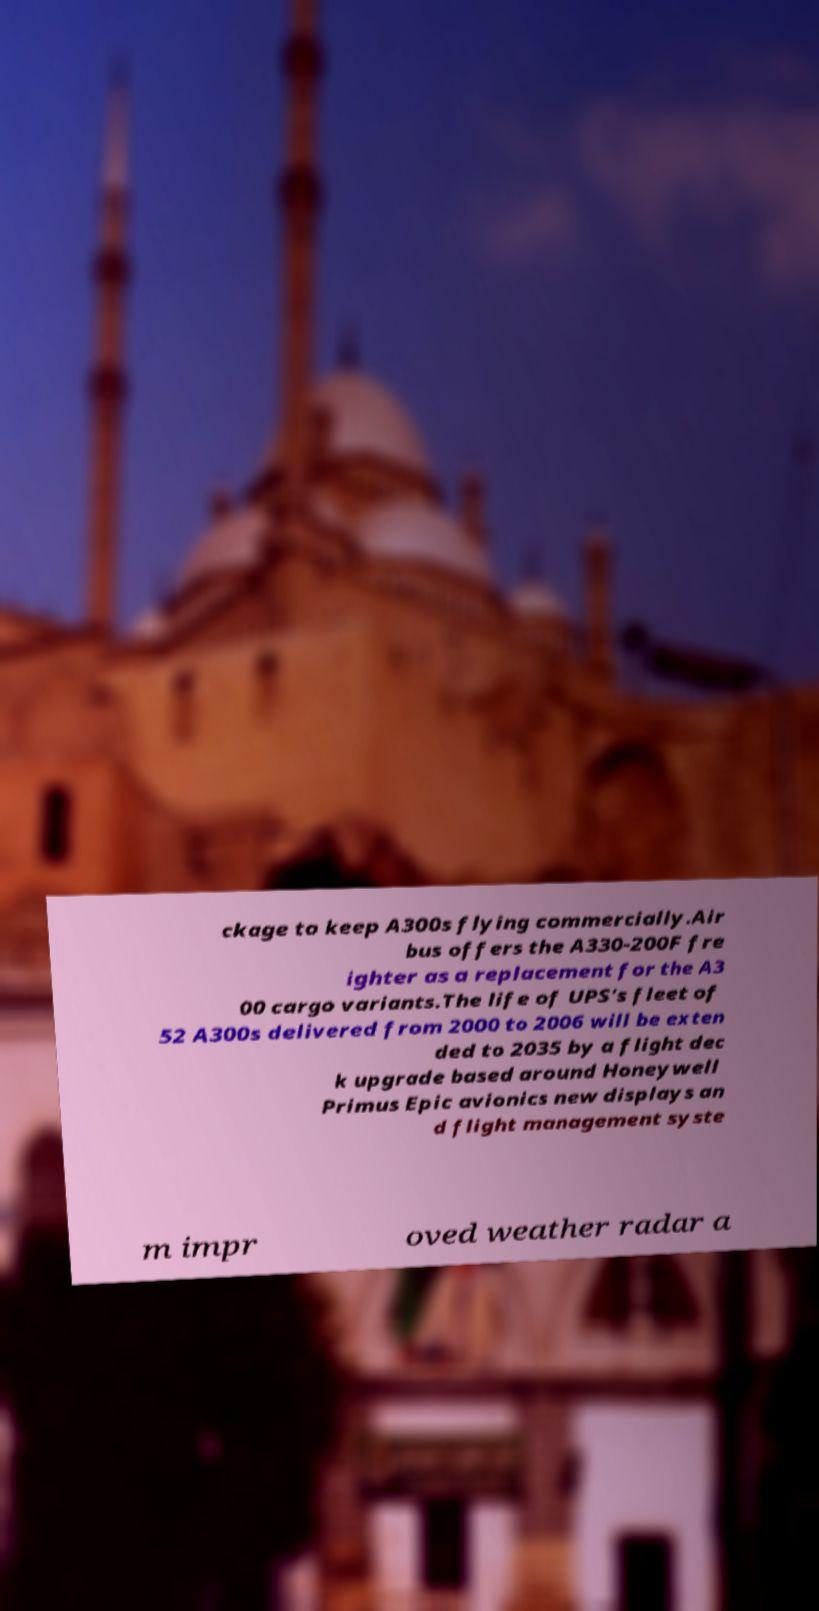Could you assist in decoding the text presented in this image and type it out clearly? ckage to keep A300s flying commercially.Air bus offers the A330-200F fre ighter as a replacement for the A3 00 cargo variants.The life of UPS's fleet of 52 A300s delivered from 2000 to 2006 will be exten ded to 2035 by a flight dec k upgrade based around Honeywell Primus Epic avionics new displays an d flight management syste m impr oved weather radar a 